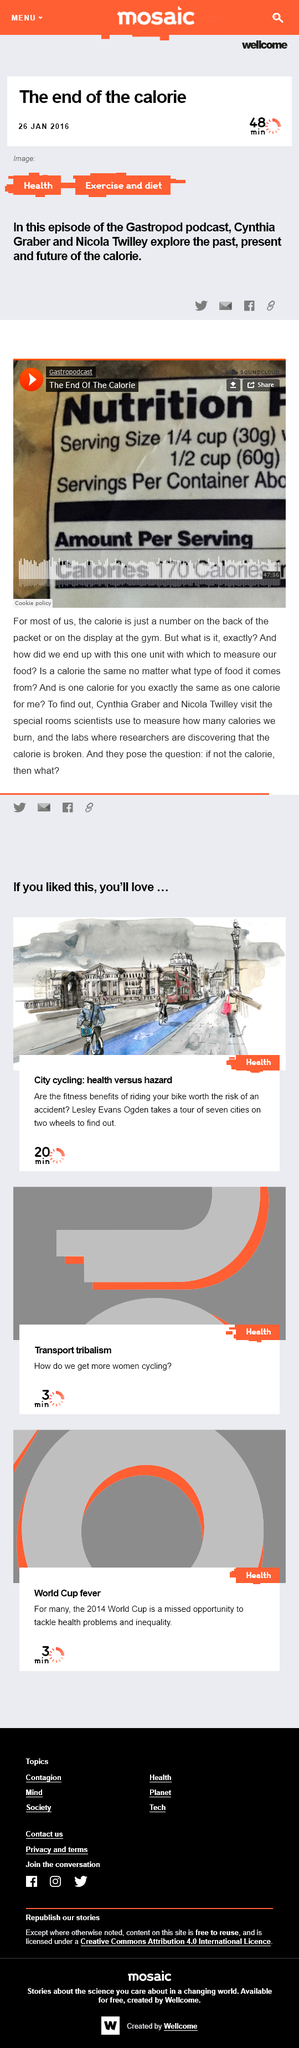Specify some key components in this picture. The Gastropod podcast features visits to special rooms where scientists measure the number of calories individuals burn. The Gastropod podcast's 'The end of the calorie' episode was released on January 26, 2016. In the Gastropod podcast, two individuals, Cynthia Graber and Nicola Twilley, are featured. 